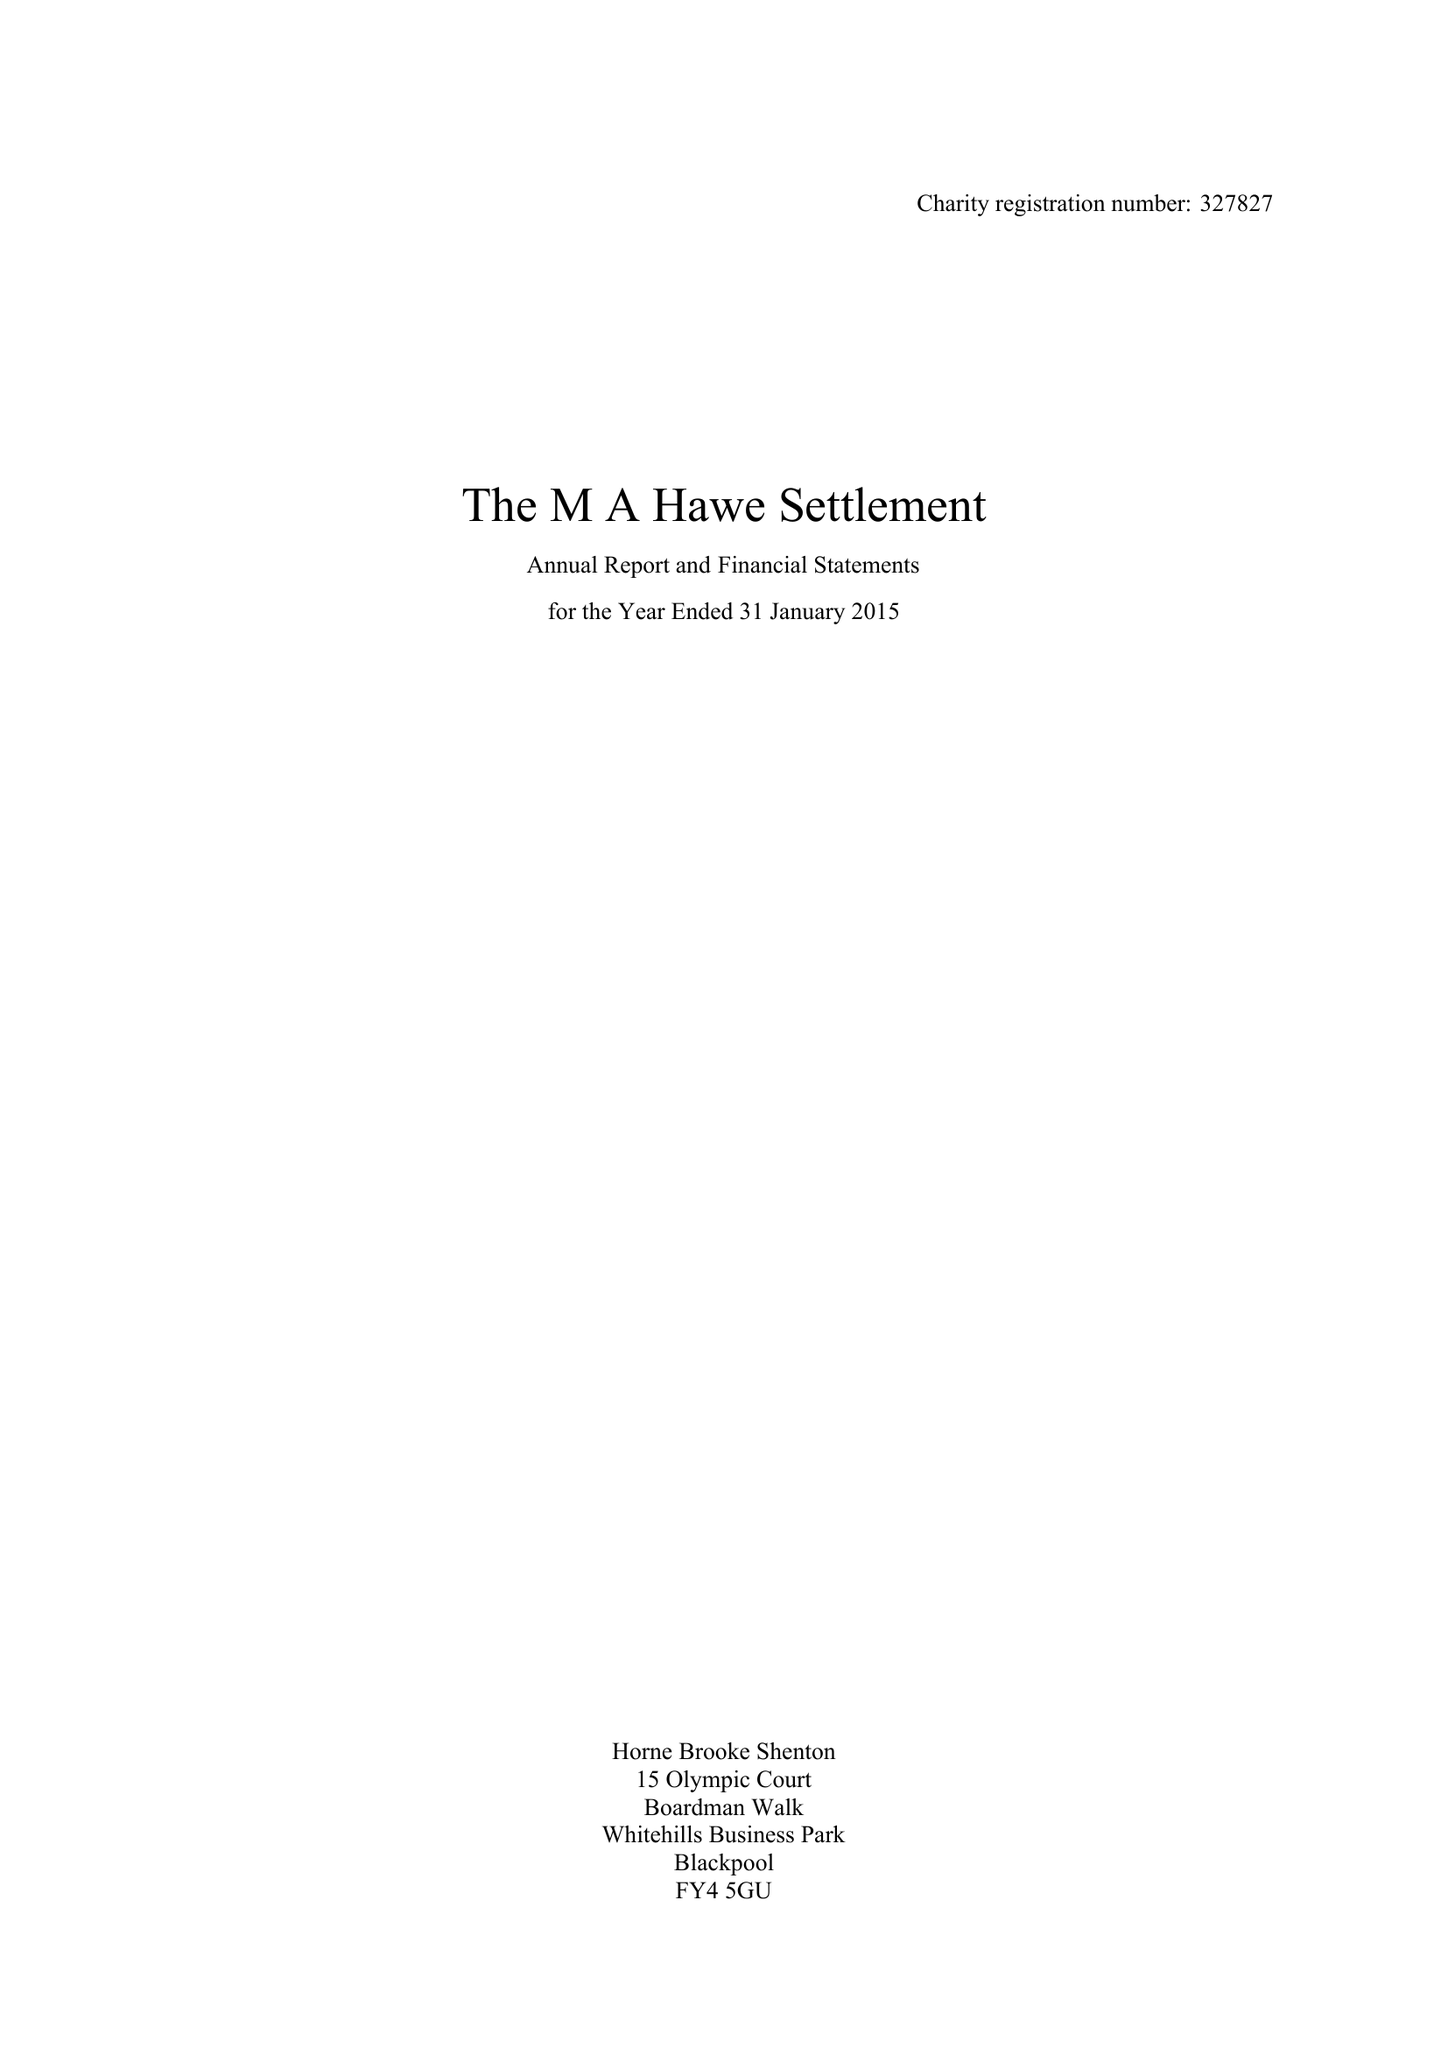What is the value for the charity_number?
Answer the question using a single word or phrase. 327827 